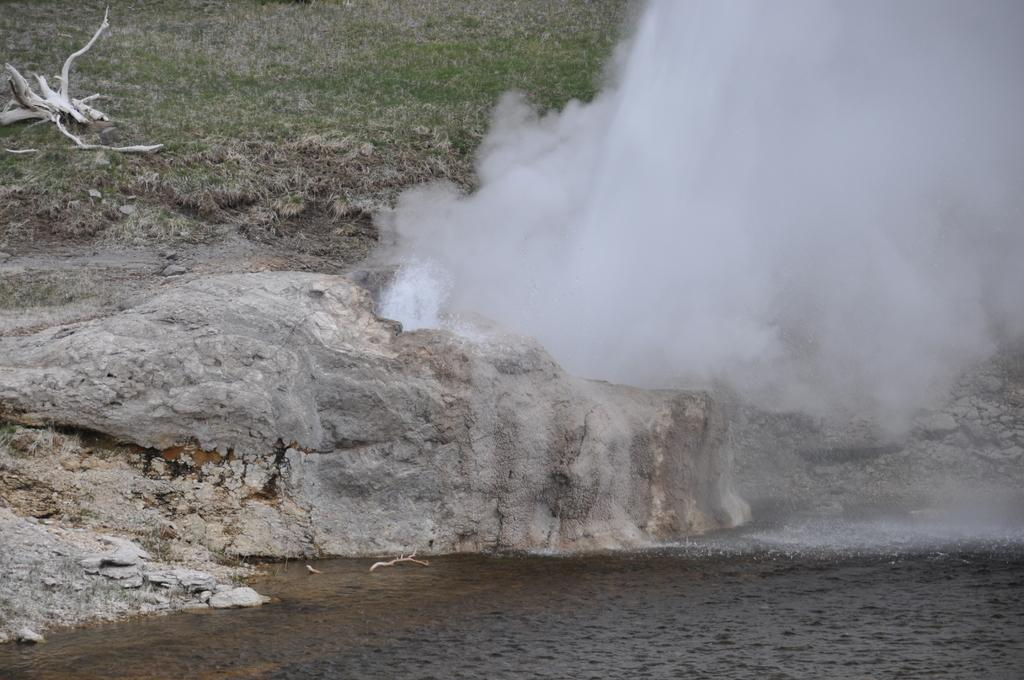What type of terrain is visible in the image? There is grassy land and a rocky surface in the image. What natural feature can be seen in the image? There is a waterfall in the image. What material is present in the image? There is wood in the image. What body of water is visible in the image? There is a water body in the image. What is the condition of the grass in the image during the month of December? The provided facts do not mention the condition of the grass or the month of December, so it cannot be determined from the image. 